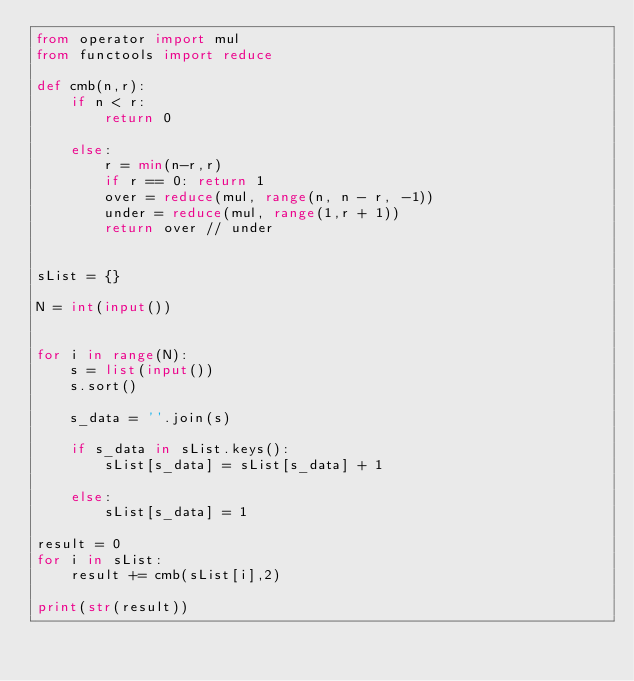<code> <loc_0><loc_0><loc_500><loc_500><_Python_>from operator import mul
from functools import reduce

def cmb(n,r):
    if n < r:
        return 0

    else:
        r = min(n-r,r)
        if r == 0: return 1
        over = reduce(mul, range(n, n - r, -1))
        under = reduce(mul, range(1,r + 1))
        return over // under


sList = {}

N = int(input())


for i in range(N):
    s = list(input())
    s.sort()

    s_data = ''.join(s)

    if s_data in sList.keys():
        sList[s_data] = sList[s_data] + 1

    else:    
        sList[s_data] = 1

result = 0
for i in sList:
    result += cmb(sList[i],2)

print(str(result))</code> 